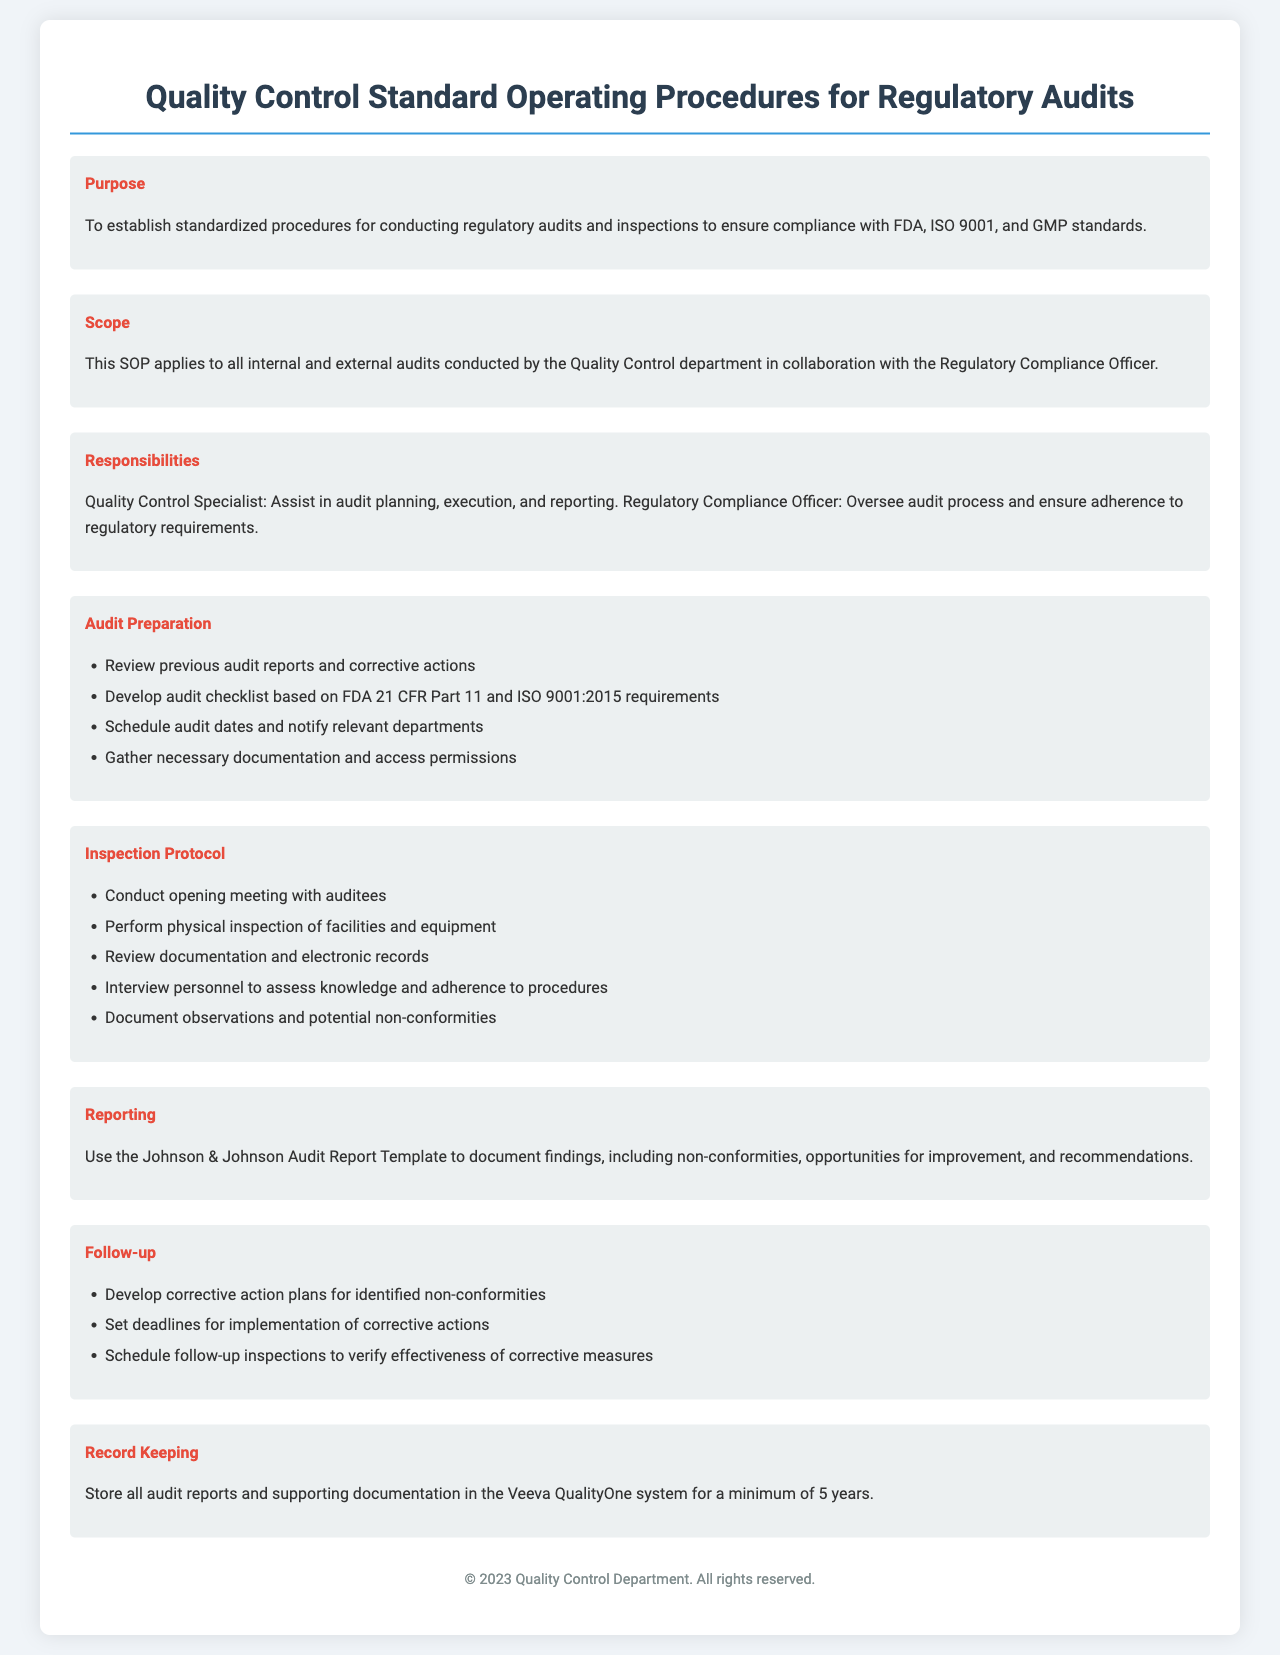What is the purpose of the SOP? The purpose is to establish standardized procedures for conducting regulatory audits and inspections.
Answer: To establish standardized procedures for conducting regulatory audits and inspections What are the key standards mentioned? The SOP mentions compliance with FDA, ISO 9001, and GMP standards.
Answer: FDA, ISO 9001, GMP Who oversees the audit process? The Regulatory Compliance Officer oversees the audit process.
Answer: Regulatory Compliance Officer What is the duration for record keeping? All audit reports and supporting documentation must be stored for a minimum of 5 years.
Answer: 5 years What is the first step in audit preparation? The first step is to review previous audit reports and corrective actions.
Answer: Review previous audit reports and corrective actions What template is used for reporting? The Johnson & Johnson Audit Report Template is used for reporting.
Answer: Johnson & Johnson Audit Report Template How should findings and recommendations be documented? Findings and recommendations should be documented using the Johnson & Johnson Audit Report Template.
Answer: Using the Johnson & Johnson Audit Report Template What is one of the follow-up actions? One of the follow-up actions is to develop corrective action plans for identified non-conformities.
Answer: Develop corrective action plans for identified non-conformities What must be gathered prior to the audit? Necessary documentation and access permissions must be gathered prior to the audit.
Answer: Necessary documentation and access permissions 